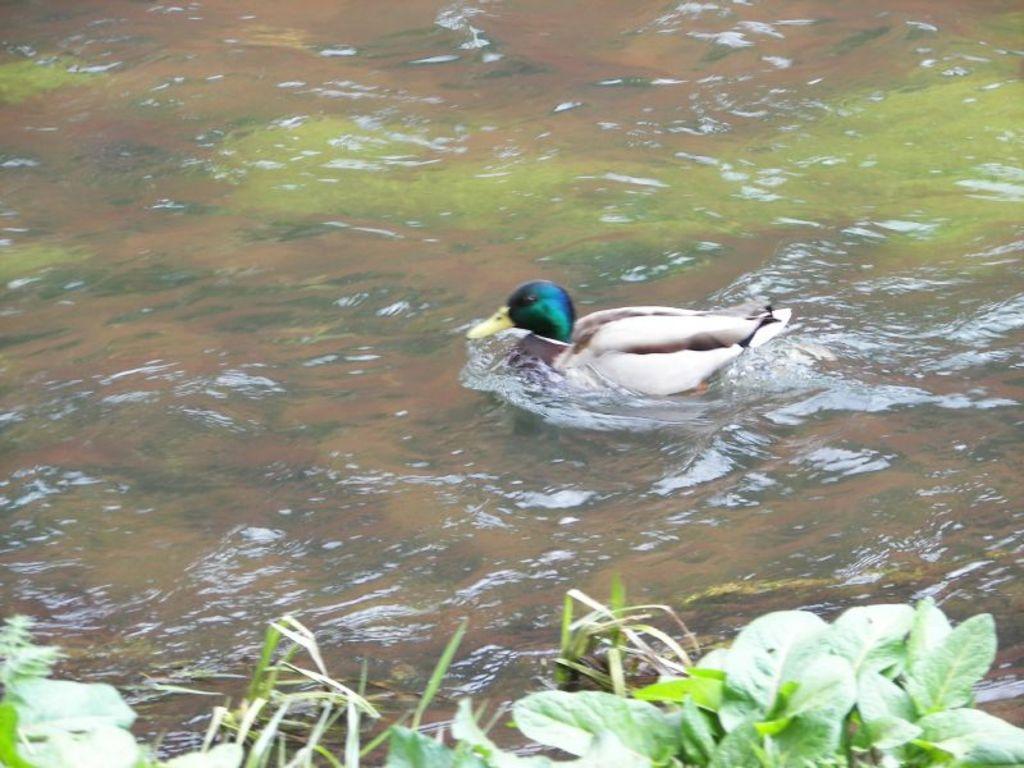Could you give a brief overview of what you see in this image? In this image I can see a bird on the water which is facing towards the left side. At the bottom of the image I can see few plants. 